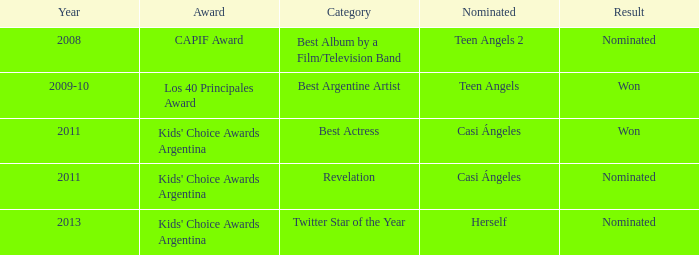What year saw an award in the category of Revelation? 2011.0. 